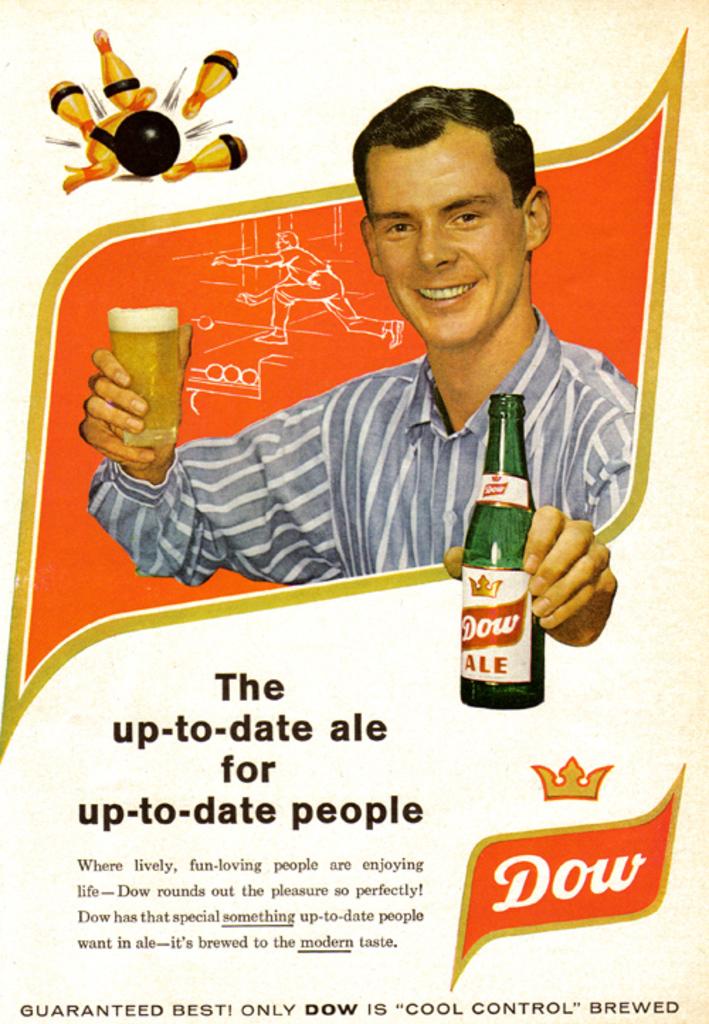Is the ale for up-to-date people?
Offer a terse response. Yes. 